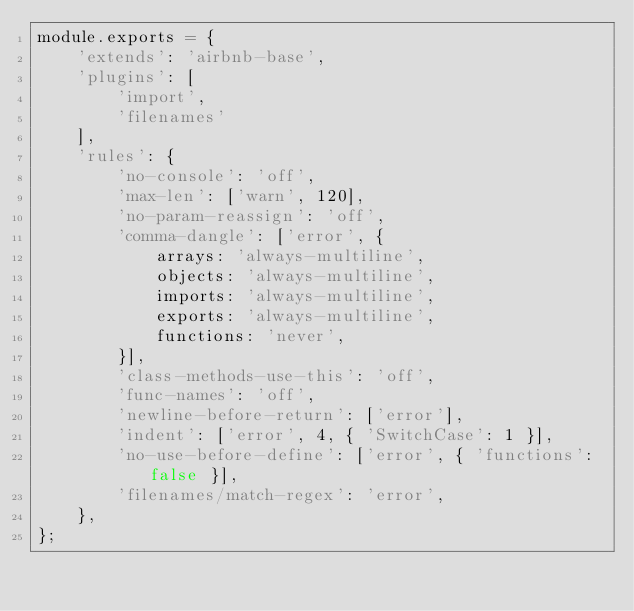Convert code to text. <code><loc_0><loc_0><loc_500><loc_500><_JavaScript_>module.exports = {
    'extends': 'airbnb-base',
    'plugins': [
        'import',
        'filenames'
    ],
    'rules': {
        'no-console': 'off',
        'max-len': ['warn', 120],
        'no-param-reassign': 'off',
        'comma-dangle': ['error', {
            arrays: 'always-multiline',
            objects: 'always-multiline',
            imports: 'always-multiline',
            exports: 'always-multiline',
            functions: 'never',
        }],
        'class-methods-use-this': 'off',
        'func-names': 'off',
        'newline-before-return': ['error'],
        'indent': ['error', 4, { 'SwitchCase': 1 }],
        'no-use-before-define': ['error', { 'functions': false }],
        'filenames/match-regex': 'error',
    },
};
</code> 